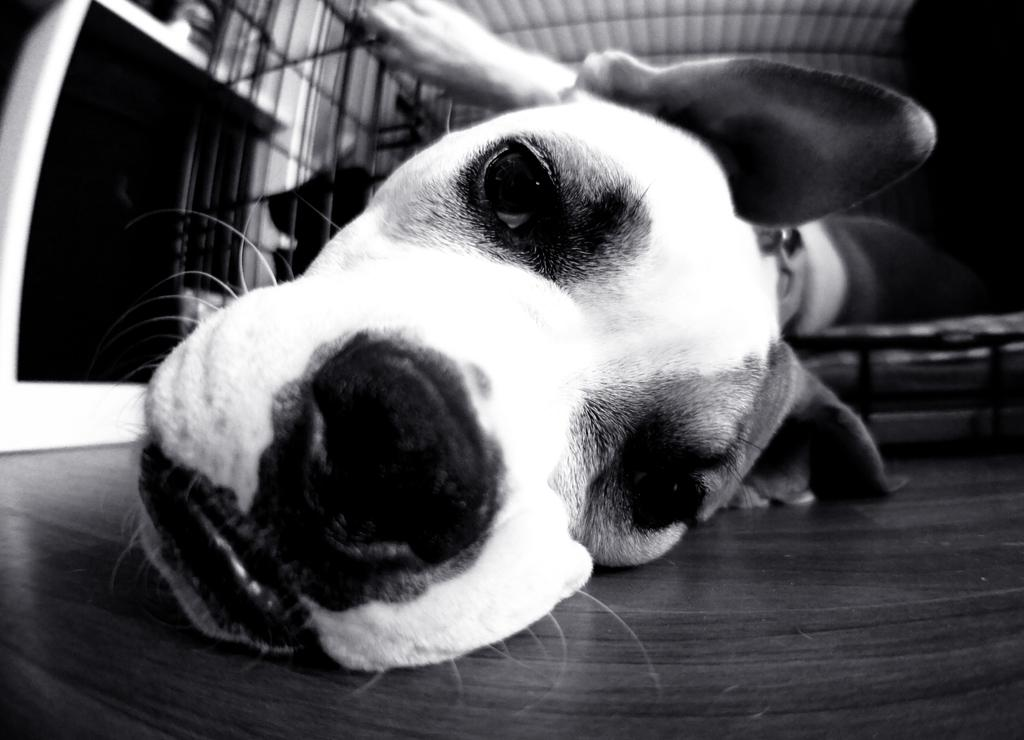What is the color scheme of the image? The image is black and white. What is the main subject of the image? There is a close-up view of a dog in the image. What is the dog's position in the image? The dog is lying on the floor. What type of flooring is visible in the image? The floor appears to be wooden. Can you see a snake slithering across the wooden floor in the image? No, there is no snake present in the image; it only features a dog lying on the wooden floor. Is the dog being pushed by someone or something in the image? No, the dog is lying on the floor without any indication of being pushed by someone or something. 